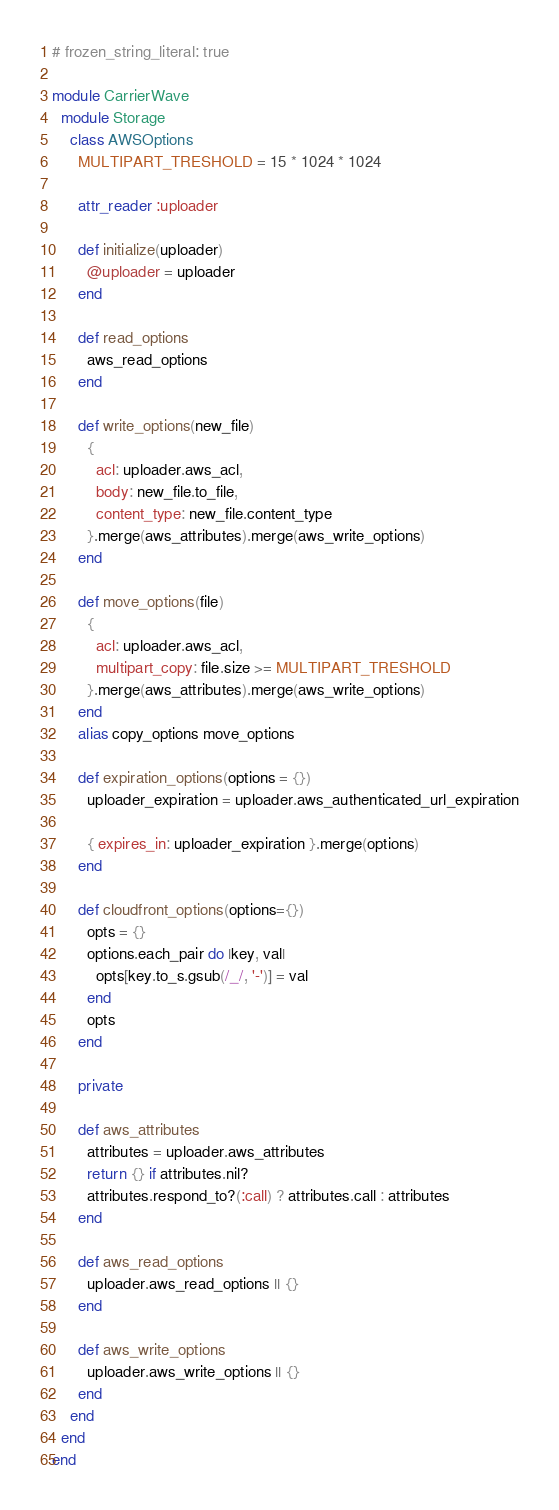<code> <loc_0><loc_0><loc_500><loc_500><_Ruby_># frozen_string_literal: true

module CarrierWave
  module Storage
    class AWSOptions
      MULTIPART_TRESHOLD = 15 * 1024 * 1024

      attr_reader :uploader

      def initialize(uploader)
        @uploader = uploader
      end

      def read_options
        aws_read_options
      end

      def write_options(new_file)
        {
          acl: uploader.aws_acl,
          body: new_file.to_file,
          content_type: new_file.content_type
        }.merge(aws_attributes).merge(aws_write_options)
      end

      def move_options(file)
        {
          acl: uploader.aws_acl,
          multipart_copy: file.size >= MULTIPART_TRESHOLD
        }.merge(aws_attributes).merge(aws_write_options)
      end
      alias copy_options move_options

      def expiration_options(options = {})
        uploader_expiration = uploader.aws_authenticated_url_expiration

        { expires_in: uploader_expiration }.merge(options)
      end

      def cloudfront_options(options={})
        opts = {}
        options.each_pair do |key, val|
          opts[key.to_s.gsub(/_/, '-')] = val
        end
        opts
      end

      private

      def aws_attributes
        attributes = uploader.aws_attributes
        return {} if attributes.nil?
        attributes.respond_to?(:call) ? attributes.call : attributes
      end

      def aws_read_options
        uploader.aws_read_options || {}
      end

      def aws_write_options
        uploader.aws_write_options || {}
      end
    end
  end
end
</code> 